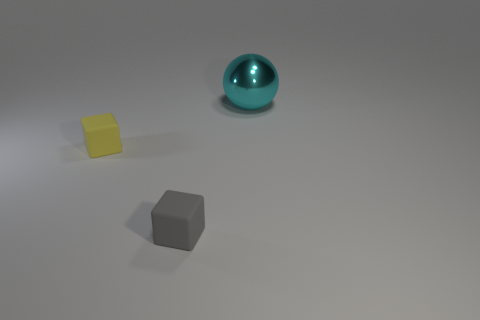There is another tiny thing that is the same shape as the yellow rubber object; what color is it?
Ensure brevity in your answer.  Gray. What number of tiny blue things have the same material as the tiny gray thing?
Your answer should be compact. 0. The sphere has what color?
Offer a very short reply. Cyan. What is the color of the other rubber cube that is the same size as the yellow block?
Provide a short and direct response. Gray. Is the shape of the object that is in front of the tiny yellow rubber object the same as the tiny rubber thing behind the gray matte object?
Provide a succinct answer. Yes. What number of other objects are the same size as the shiny sphere?
Offer a terse response. 0. Is the number of large metallic balls on the right side of the big sphere less than the number of tiny blocks that are in front of the yellow rubber object?
Give a very brief answer. Yes. There is a object that is left of the large cyan sphere and on the right side of the tiny yellow block; what is its color?
Your response must be concise. Gray. Is the size of the metal ball the same as the thing that is on the left side of the tiny gray matte cube?
Give a very brief answer. No. There is a big metallic thing on the right side of the yellow block; what is its shape?
Keep it short and to the point. Sphere. 